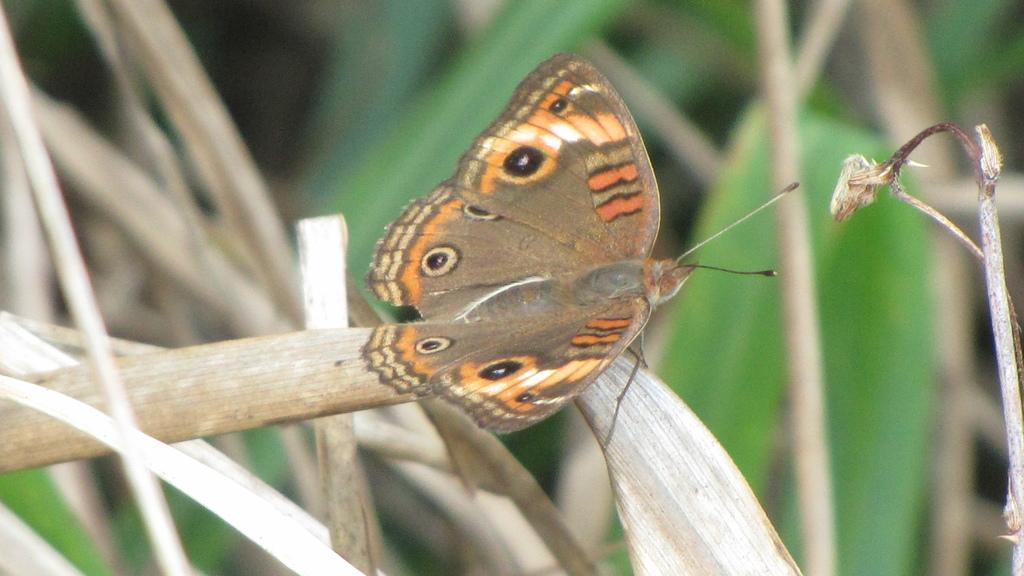What is the main subject in the image? There is a butterfly in the image. What is the butterfly resting on? The butterfly is on dry leaves. Where is the butterfly located in the image? The butterfly is in the foreground area of the image. What type of street is visible in the image? There is no street present in the image; it features a butterfly on dry leaves. How does the butterfly experience loss in the image? The butterfly does not experience loss in the image; it is simply resting on dry leaves. 